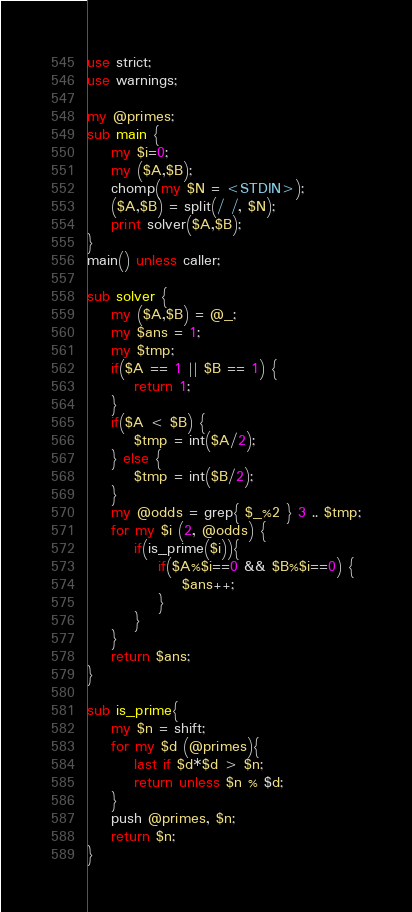<code> <loc_0><loc_0><loc_500><loc_500><_Perl_>use strict;
use warnings;

my @primes;
sub main {
    my $i=0;
    my ($A,$B);
    chomp(my $N = <STDIN>);
    ($A,$B) = split(/ /, $N);
    print solver($A,$B);
}
main() unless caller;

sub solver {
    my ($A,$B) = @_;
    my $ans = 1;
    my $tmp;
    if($A == 1 || $B == 1) {
        return 1;
    }
    if($A < $B) {
        $tmp = int($A/2);
    } else {
        $tmp = int($B/2);
    }
    my @odds = grep{ $_%2 } 3 .. $tmp;
    for my $i (2, @odds) {
        if(is_prime($i)){
            if($A%$i==0 && $B%$i==0) {
                $ans++;
            }
        }
    }
    return $ans;
}

sub is_prime{
    my $n = shift;
    for my $d (@primes){
        last if $d*$d > $n;
        return unless $n % $d;
    }
    push @primes, $n;
    return $n;
}</code> 